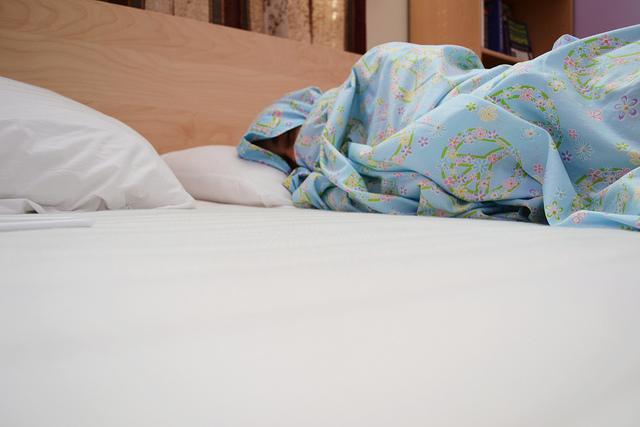Is the blanket patterned?
Quick response, please. Yes. What symbol is on the blue blanket?
Give a very brief answer. Peace. Is this bed made?
Be succinct. No. 